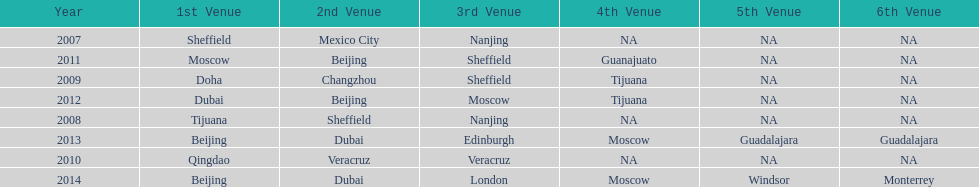How long, in years, has the this world series been occurring? 7 years. 